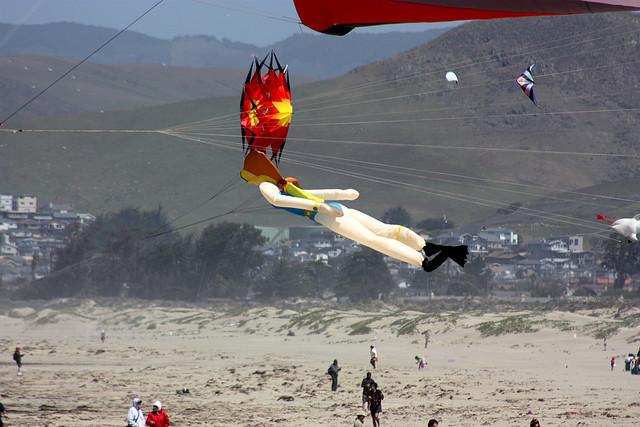Is the kite on fire?
Write a very short answer. No. Are there more than one person flying kites?
Be succinct. Yes. What type of terrain is in the background?
Give a very brief answer. Mountain. 